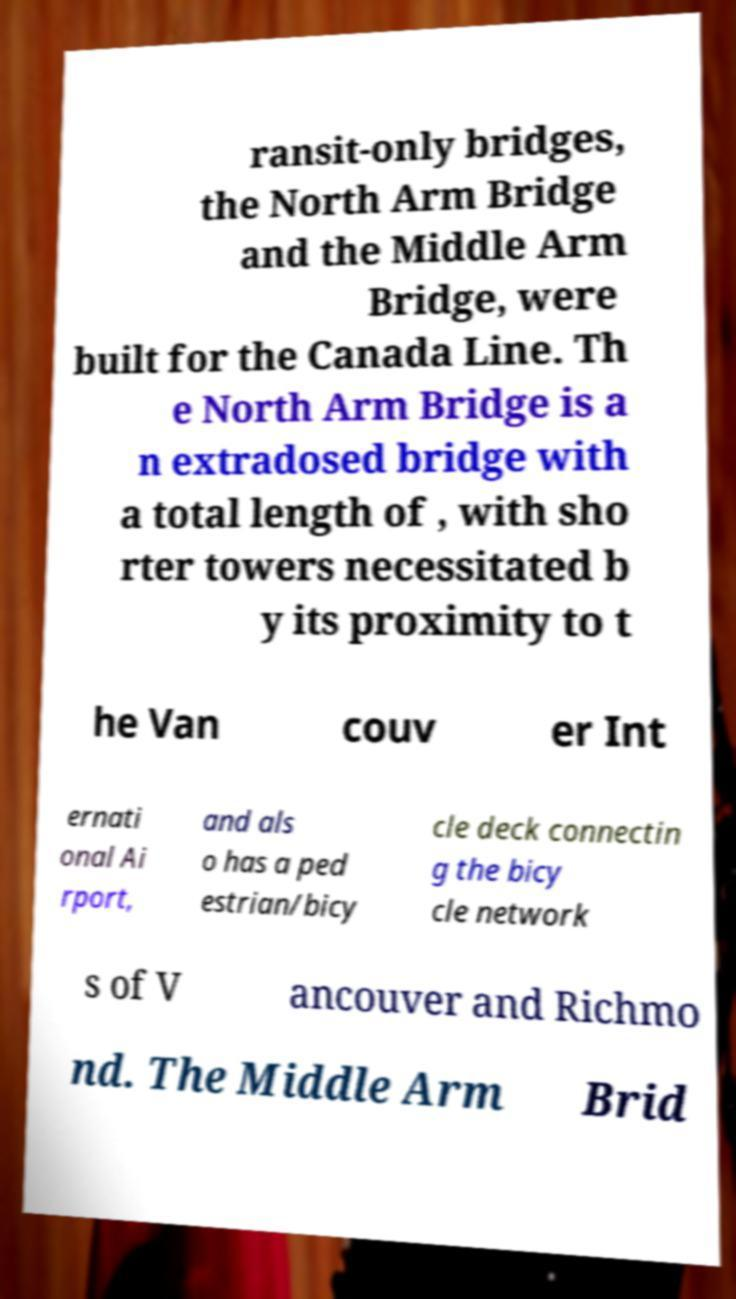Please identify and transcribe the text found in this image. ransit-only bridges, the North Arm Bridge and the Middle Arm Bridge, were built for the Canada Line. Th e North Arm Bridge is a n extradosed bridge with a total length of , with sho rter towers necessitated b y its proximity to t he Van couv er Int ernati onal Ai rport, and als o has a ped estrian/bicy cle deck connectin g the bicy cle network s of V ancouver and Richmo nd. The Middle Arm Brid 